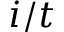Convert formula to latex. <formula><loc_0><loc_0><loc_500><loc_500>i / t</formula> 